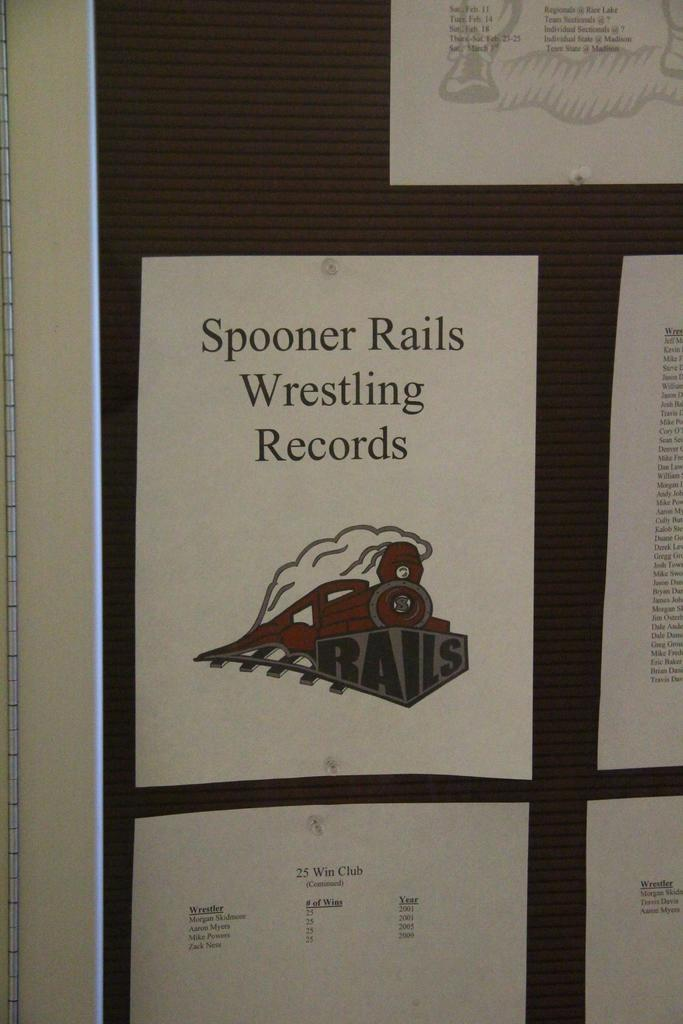<image>
Render a clear and concise summary of the photo. A billboard has sheets of paper on it and one says Spooner Rails Wrestling Records. 